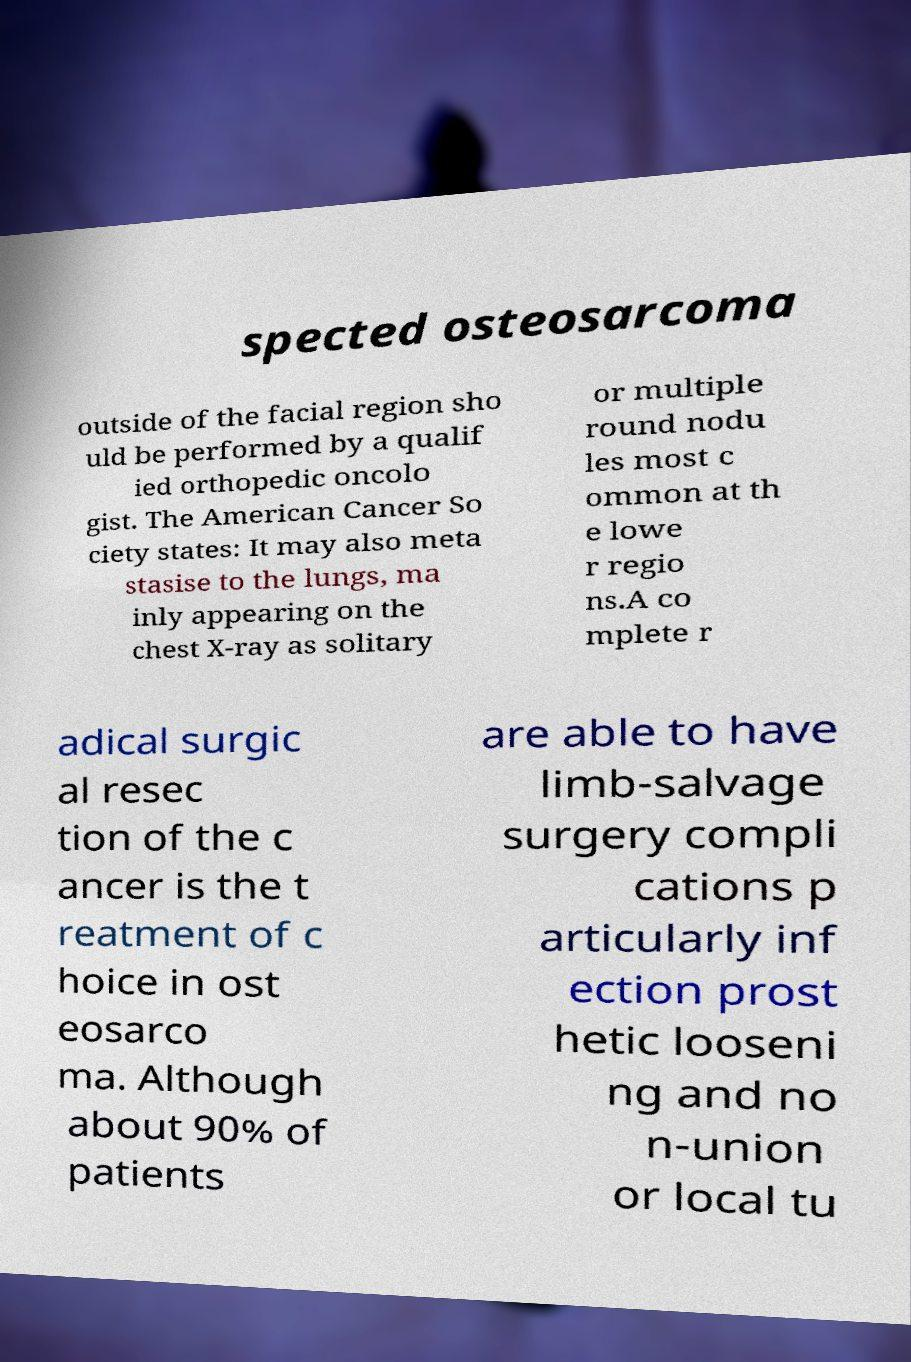Please identify and transcribe the text found in this image. spected osteosarcoma outside of the facial region sho uld be performed by a qualif ied orthopedic oncolo gist. The American Cancer So ciety states: It may also meta stasise to the lungs, ma inly appearing on the chest X-ray as solitary or multiple round nodu les most c ommon at th e lowe r regio ns.A co mplete r adical surgic al resec tion of the c ancer is the t reatment of c hoice in ost eosarco ma. Although about 90% of patients are able to have limb-salvage surgery compli cations p articularly inf ection prost hetic looseni ng and no n-union or local tu 